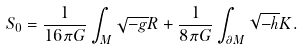<formula> <loc_0><loc_0><loc_500><loc_500>S _ { 0 } = \frac { 1 } { 1 6 \pi G } \int _ { M } \sqrt { - g } R + \frac { 1 } { 8 \pi G } \int _ { \partial M } \sqrt { - h } K .</formula> 